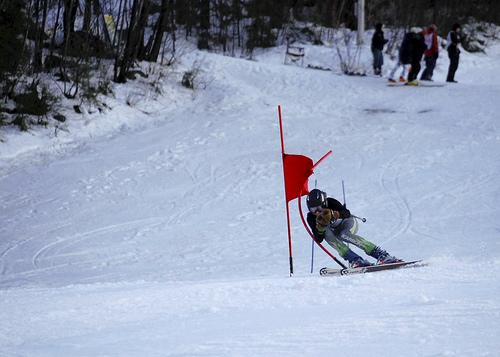What is the person doing in the middle of the picture?
Give a very brief answer. Skiing. Is skiing a competitive sport?
Concise answer only. Yes. Is this area flat?
Give a very brief answer. No. 